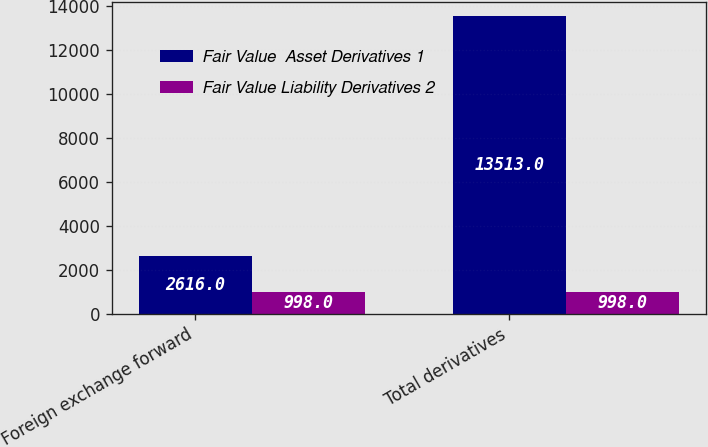Convert chart. <chart><loc_0><loc_0><loc_500><loc_500><stacked_bar_chart><ecel><fcel>Foreign exchange forward<fcel>Total derivatives<nl><fcel>Fair Value  Asset Derivatives 1<fcel>2616<fcel>13513<nl><fcel>Fair Value Liability Derivatives 2<fcel>998<fcel>998<nl></chart> 